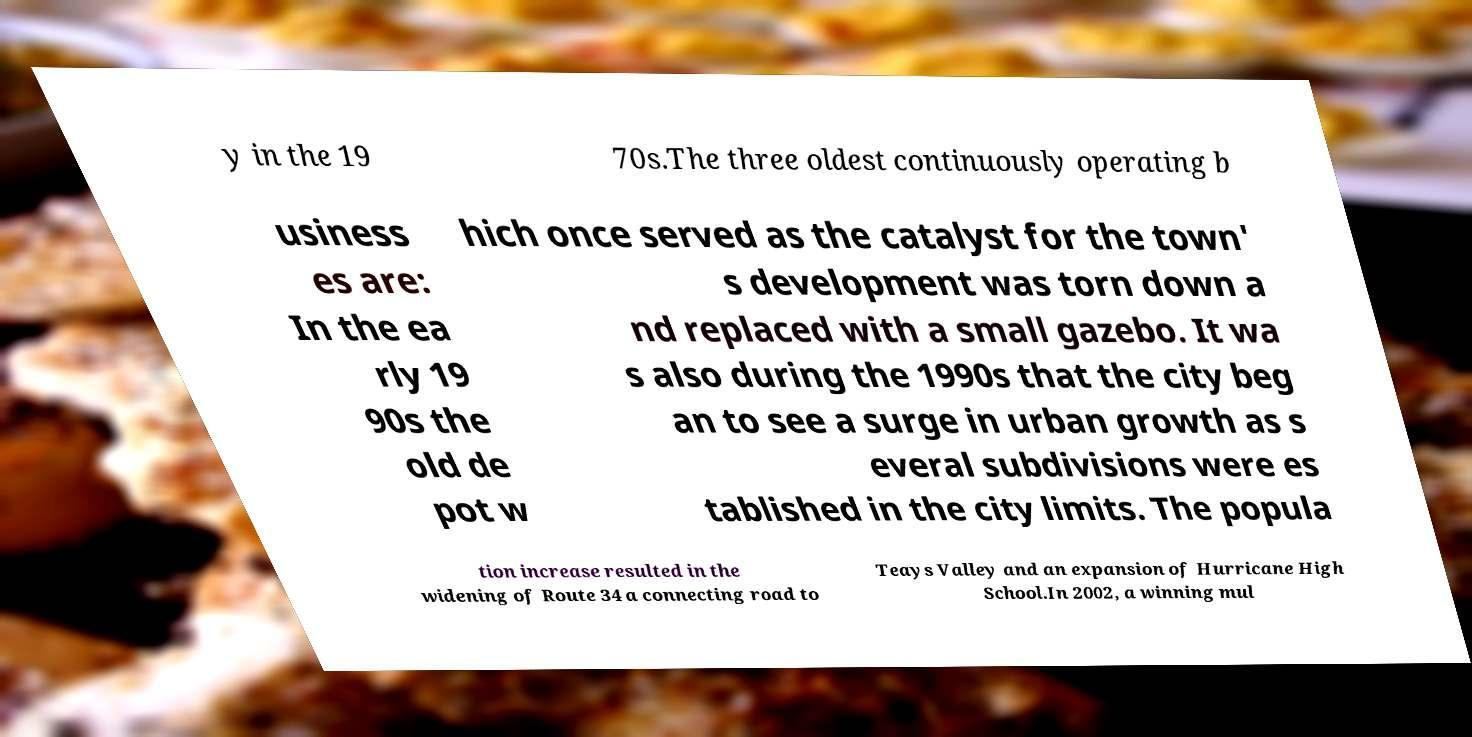Please read and relay the text visible in this image. What does it say? y in the 19 70s.The three oldest continuously operating b usiness es are: In the ea rly 19 90s the old de pot w hich once served as the catalyst for the town' s development was torn down a nd replaced with a small gazebo. It wa s also during the 1990s that the city beg an to see a surge in urban growth as s everal subdivisions were es tablished in the city limits. The popula tion increase resulted in the widening of Route 34 a connecting road to Teays Valley and an expansion of Hurricane High School.In 2002, a winning mul 